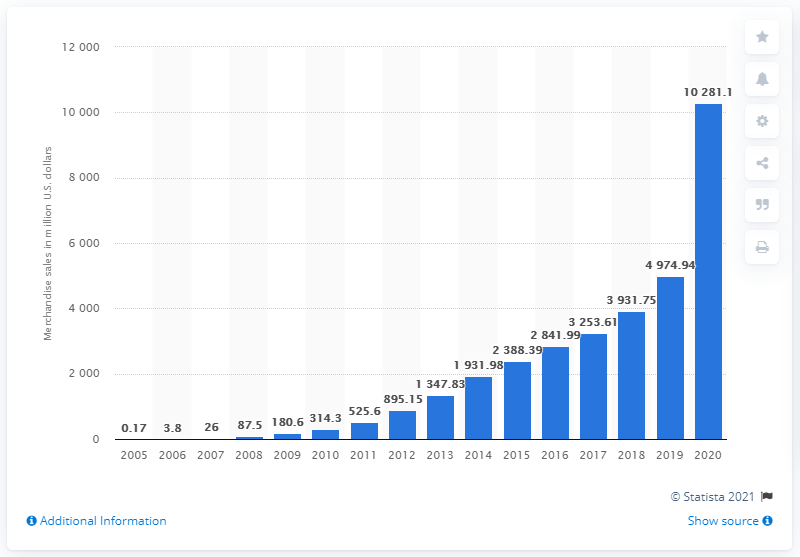Can you tell me how the sales volume of Etsy in 2020 compares to that of 2019? Absolutely, the data shown in the image indicates a notable increase in sales volume for Etsy in 2020 compared to 2019. It surged from roughly $4.97 billion in 2019 to about $10.28 billion in 2020, which is more than a 100% uptick, illustrating a booming year for the online marketplace. 